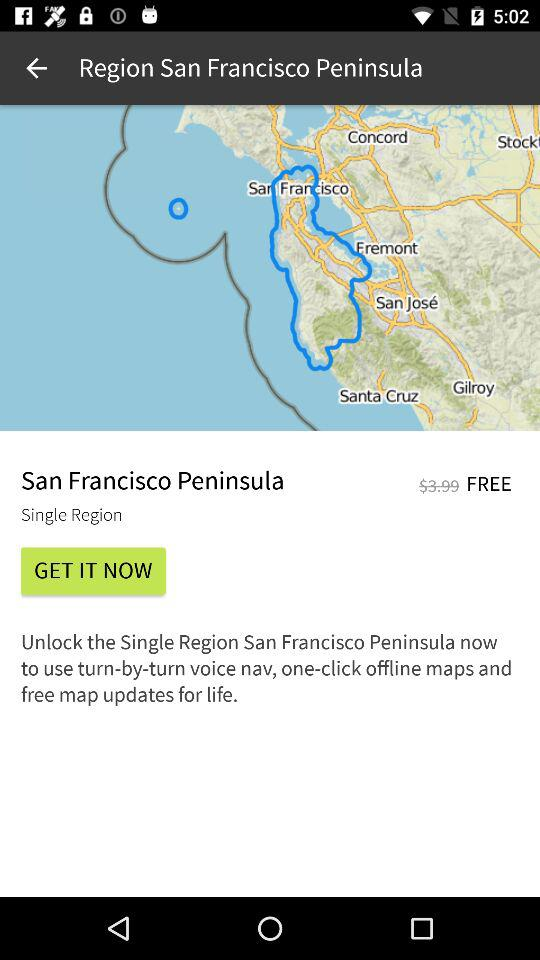What is the price to unlock the single region of the San Francisco Peninsula? The price to unlock the single region of the San Francisco Peninsula is free. 